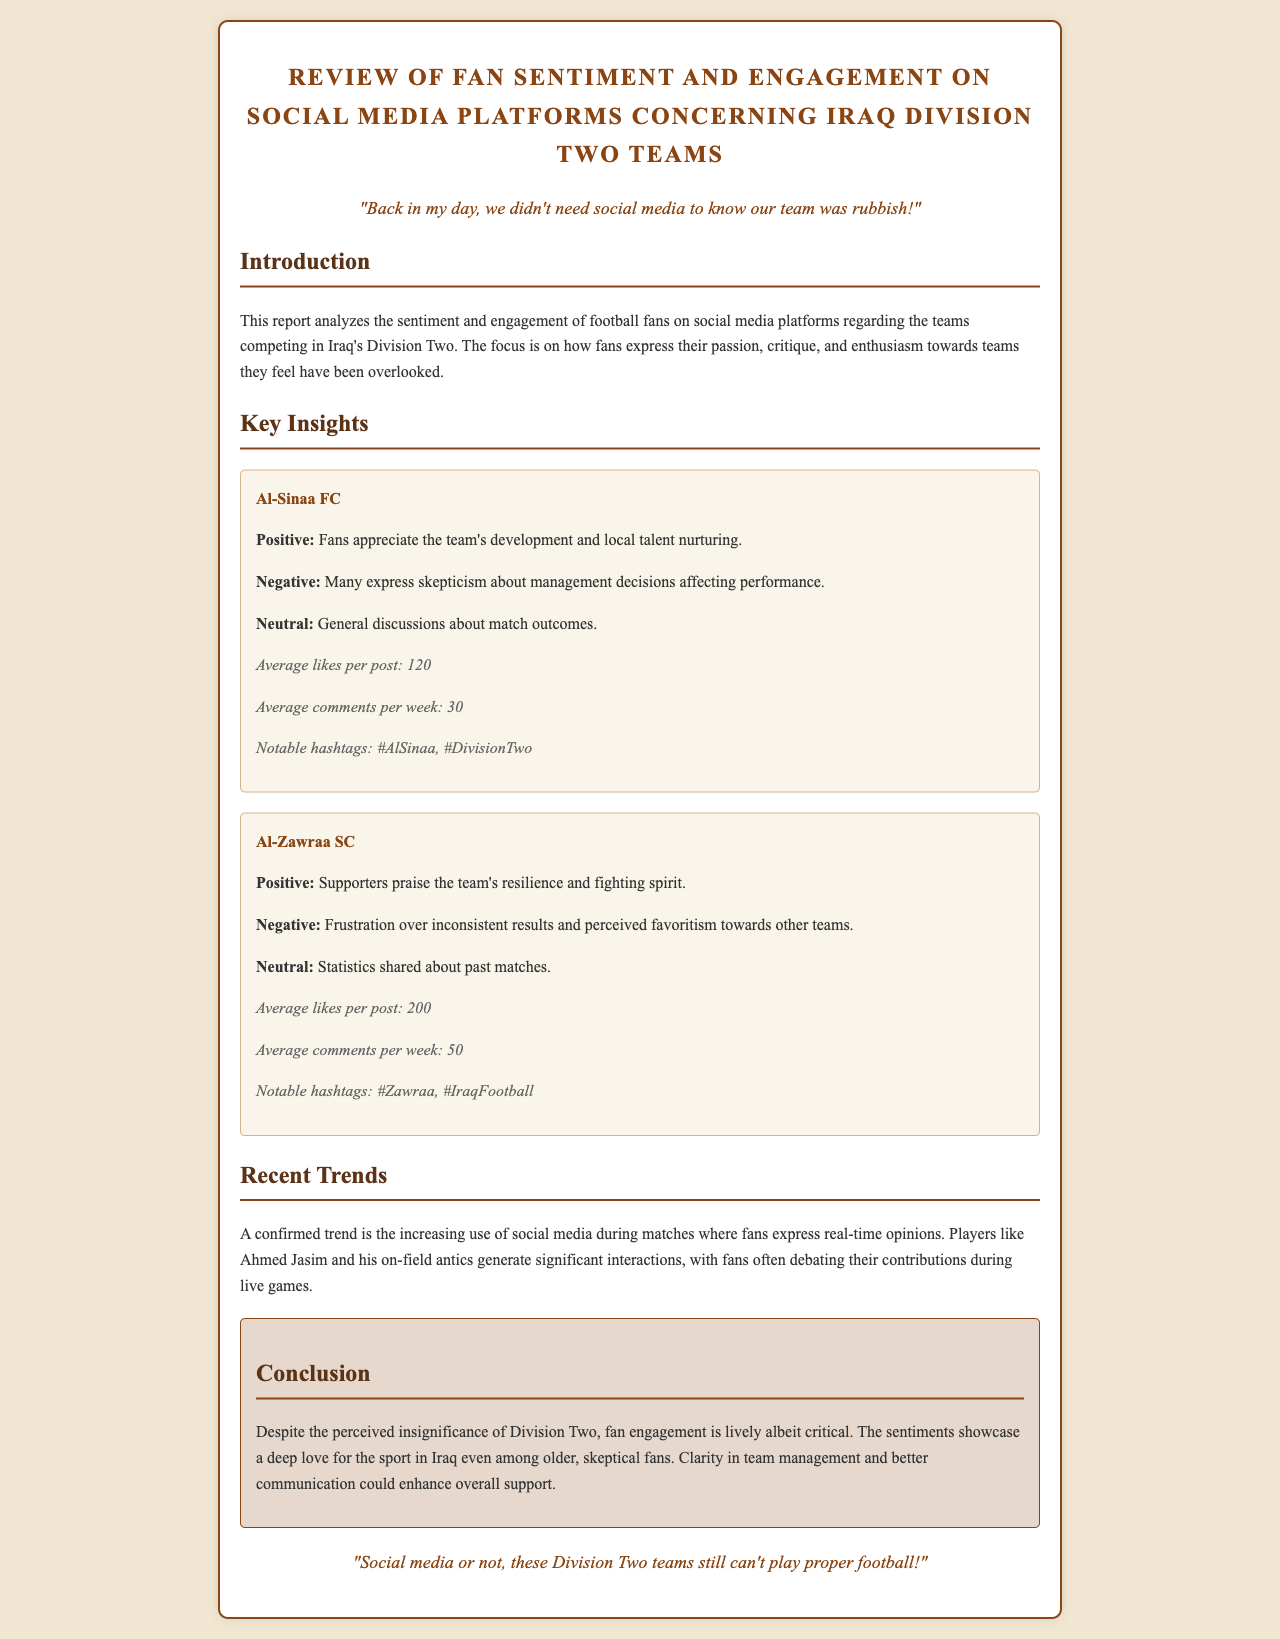What is the average number of likes per post for Al-Sinaa FC? The document states that Al-Sinaa FC receives an average of 120 likes per post.
Answer: 120 What sentiment is expressed towards Al-Zawraa SC's performance? Fans express frustration over inconsistent results and perceived favoritism towards other teams, indicating a negative sentiment.
Answer: Negative What notable hashtag is associated with Al-Sinaa FC? The report lists #AlSinaa as a notable hashtag associated with the team.
Answer: #AlSinaa How many average comments per week does Al-Zawraa SC get? According to the document, Al-Zawraa SC gets an average of 50 comments per week.
Answer: 50 What general trend regarding social media engagement is mentioned in the report? The report mentions the increasing use of social media during matches to express real-time opinions.
Answer: Increasing use during matches What is the overall sentiment regarding Iraq Division Two teams, according to the conclusion? The conclusion states that despite perceived insignificance, fan engagement is lively albeit critical.
Answer: Lively albeit critical Who is mentioned as a player generating significant interactions? Ahmed Jasim is mentioned as a player attracting significant fan interactions.
Answer: Ahmed Jasim What is the overall theme of the report concerning fan engagement? The report indicates that clarity in team management and better communication could enhance overall support from fans.
Answer: Enhance overall support 